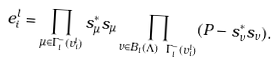<formula> <loc_0><loc_0><loc_500><loc_500>e _ { i } ^ { l } = \prod _ { \mu \in \Gamma _ { l } ^ { - } ( v _ { i } ^ { l } ) } s _ { \mu } ^ { * } s _ { \mu } \prod _ { \nu \in B _ { l } ( \Lambda ) \ \Gamma _ { l } ^ { - } ( v _ { i } ^ { l } ) } ( P - s _ { \nu } ^ { * } s _ { \nu } ) .</formula> 